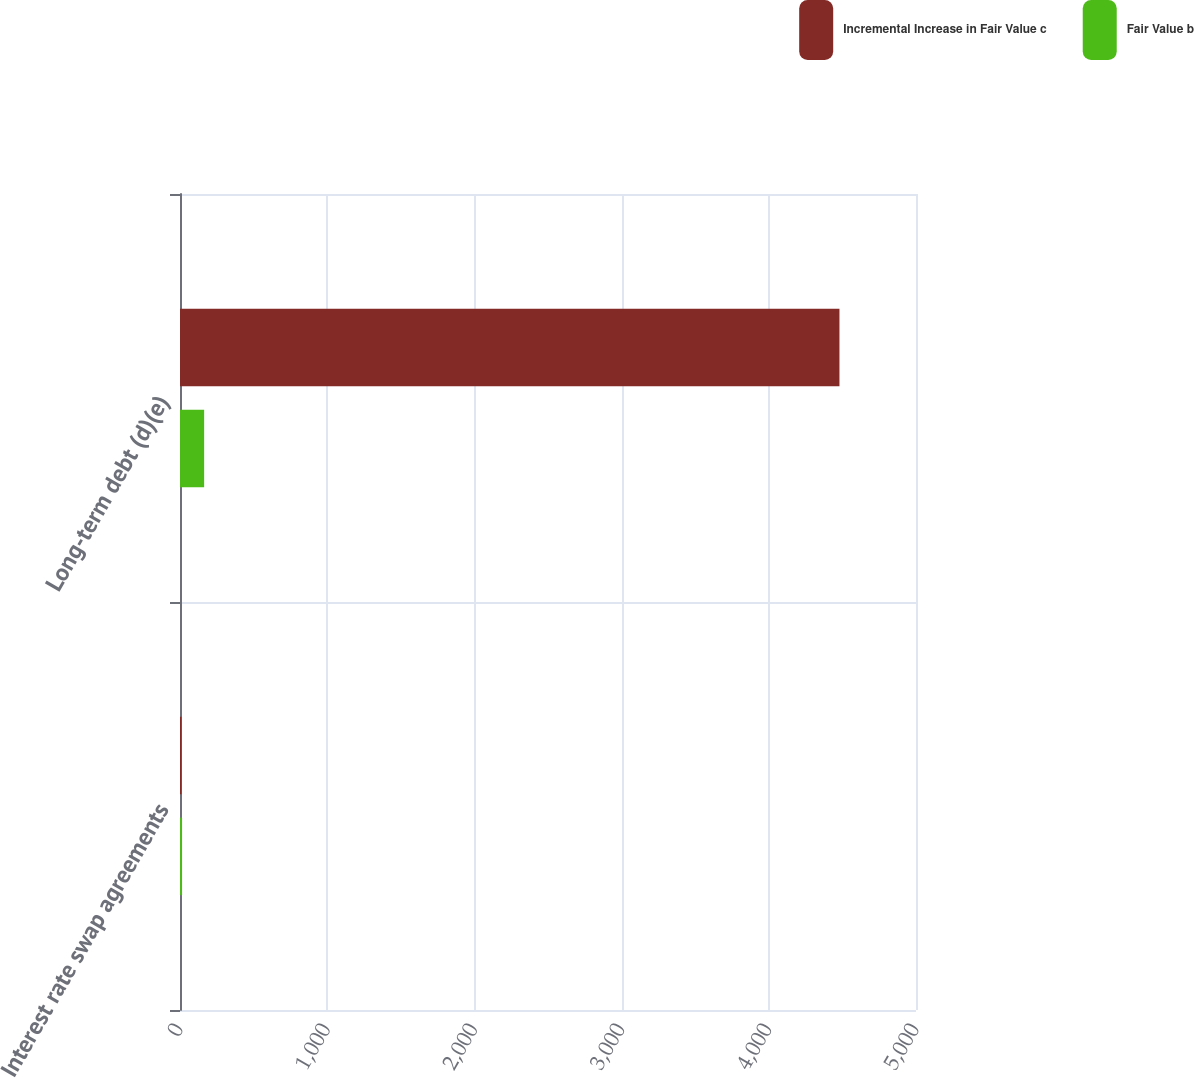Convert chart to OTSL. <chart><loc_0><loc_0><loc_500><loc_500><stacked_bar_chart><ecel><fcel>Interest rate swap agreements<fcel>Long-term debt (d)(e)<nl><fcel>Incremental Increase in Fair Value c<fcel>10<fcel>4480<nl><fcel>Fair Value b<fcel>14<fcel>164<nl></chart> 